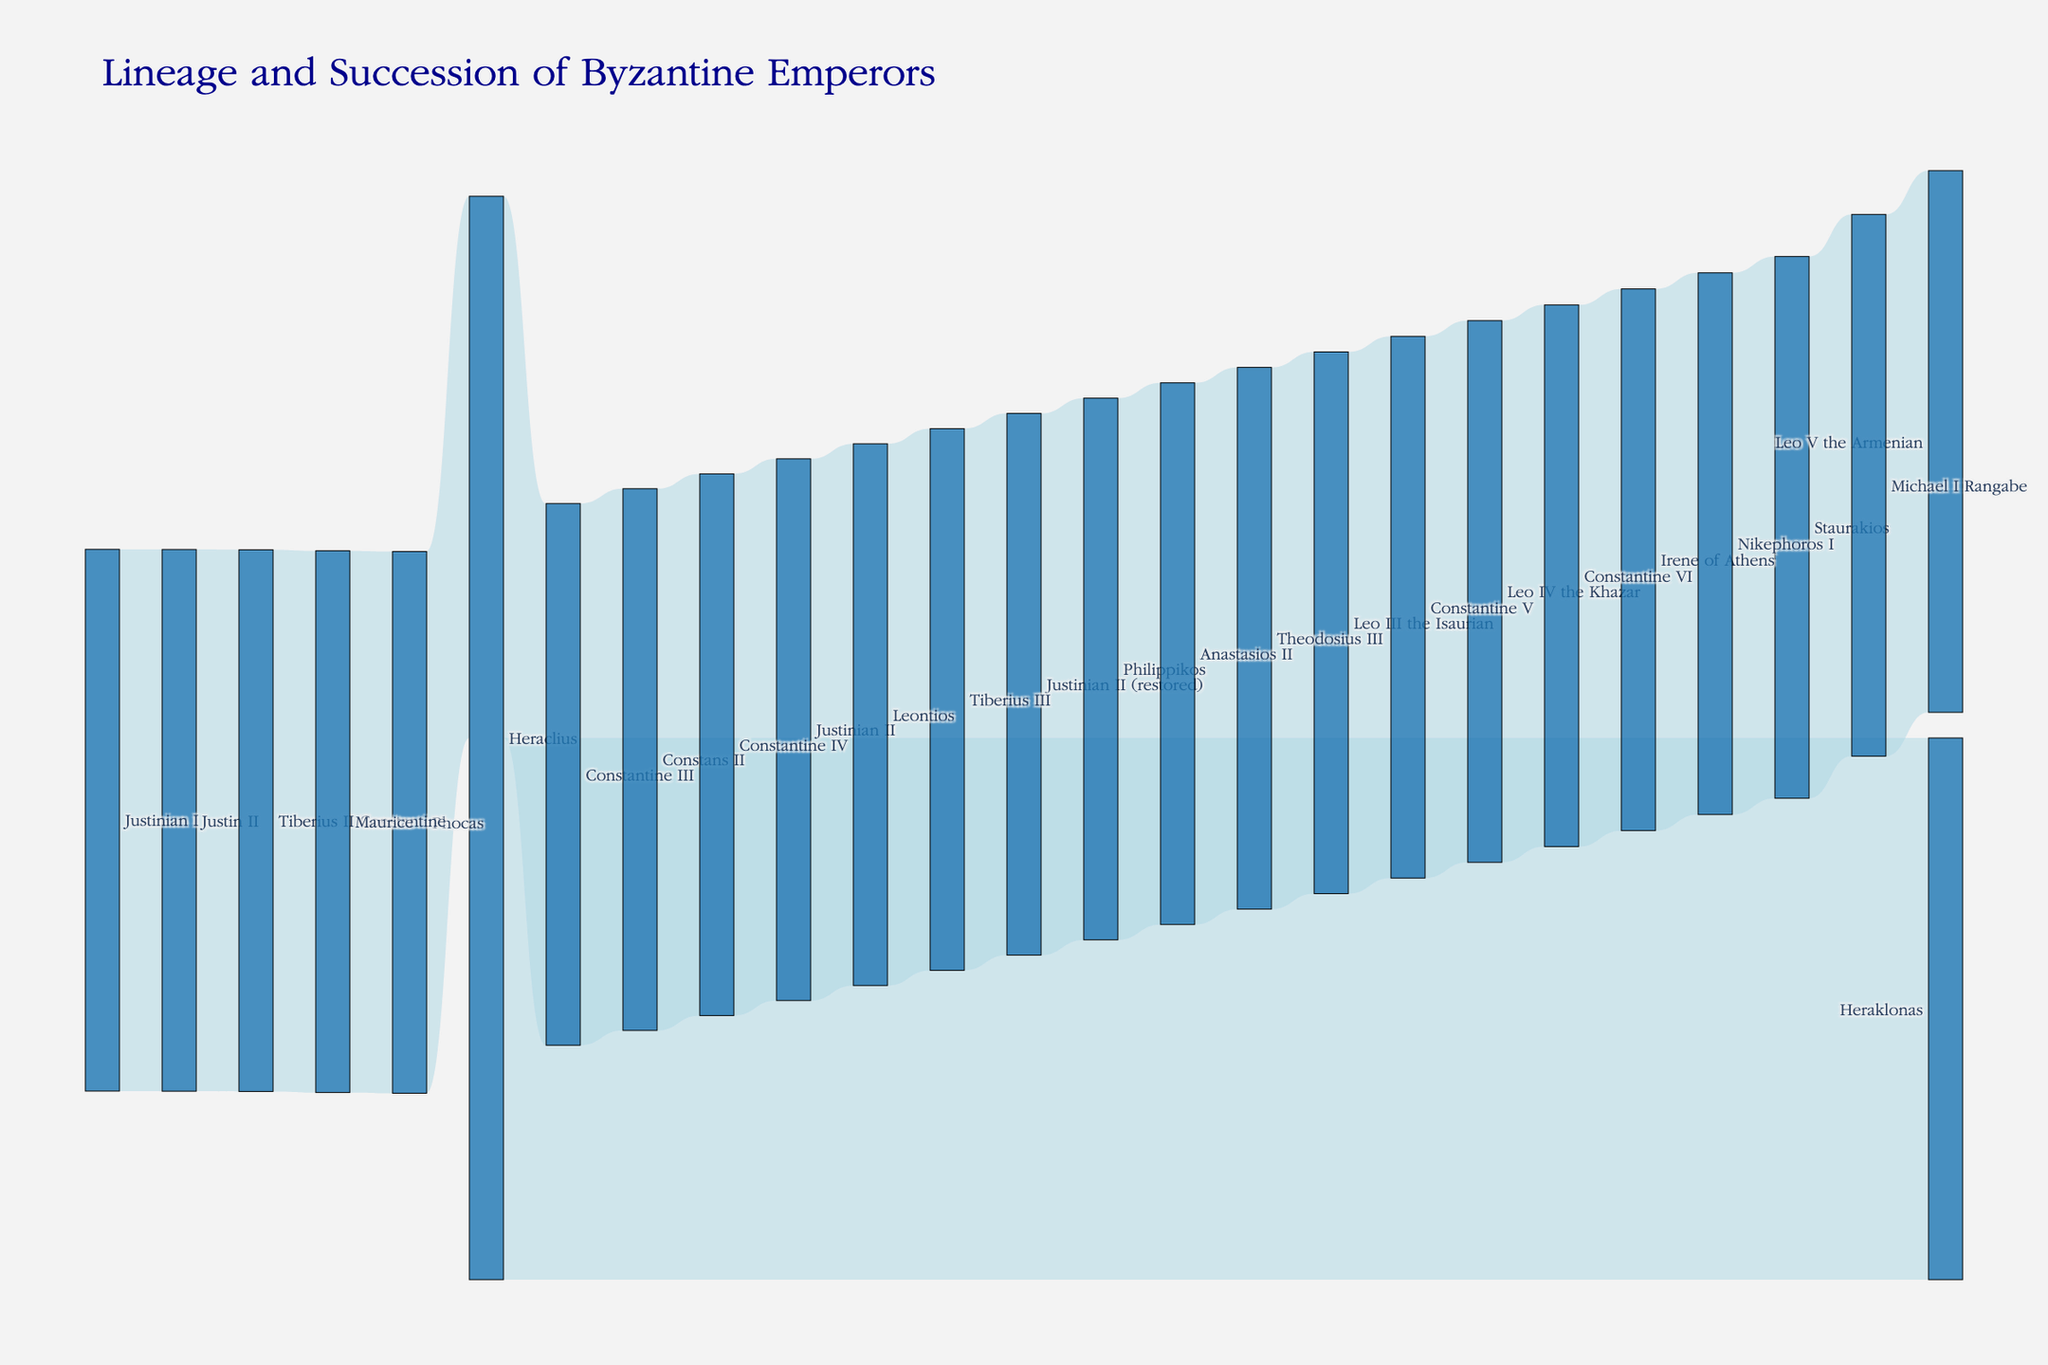What is the title of the figure? The title is typically found at the top of the figure and provides the main description of what the visualization represents.
Answer: Lineage and Succession of Byzantine Emperors How many emperors are mentioned in the diagram? To find the number of emperors, count all the unique names in the nodes.
Answer: 26 Who succeeded Justinian I? The successors are indicated by arrows leading from one node to another. Follow the arrow from Justinian I.
Answer: Justin II Who was both succeeded and restored as emperor? Look for a node with arrows pointing both away and toward it, indicating loss and regaining of power.
Answer: Justinian II How many successions occurred after the reign of Constans II? Trace the arrows starting from Constans II, counting each transfer of power.
Answer: 4 Compare the color and thickness of the nodes and links in the diagram. What do the color and thickness represent? Nodes have a solid color, and links are semi-transparent. The thickness of the links can indicate the value or weight of the connection, but they all appear similar in this diagram due to equal values.
Answer: Nodes represent emperors; links represent succession Which emperor succeeded both Constantine III and Heraklonas? Check to see which emperors are connected to both Constantine III and Heraklonas through arrows. Here, separate successors from Constantine III and Heraklonas are shown. Only intersecting lines should not be confused with a common successor.
Answer: None What is the sequence of emperors starting from Heraclius and ending at Constantine VI? Follow the links from Heraclius to each subsequent node until reaching Constantine VI.
Answer: Heraclius → Constantine III → Constans II → Constantine IV → Justinian II → Leontios → Tiberius III → Justinian II (restored) → Philippikos → Anastasios II → Theodosius III → Leo III the Isaurian → Constantine V → Leo IV the Khazar → Constantine VI How many emperors had a successor named after them? Count those nodes where the successor retains the same name. In this diagram, look for distinctions like "Justinian II (restored)" to see repeated names.
Answer: 1 (Justinian II) Who succeeded Nikephoros I, and how many lines of succession did it involve? Identify the node for Nikephoros I and trace all the arrows to subsequent nodes. Only one direct line of succession matters unless direct descendants succeed each other continuously.
Answer: Staurakios (1 line) Which emperor was dethroned and succeeded immediately by Irene of Athens? Follow arrows leading directly to Irene of Athens to identify the previous emperor.
Answer: Constantine VI 